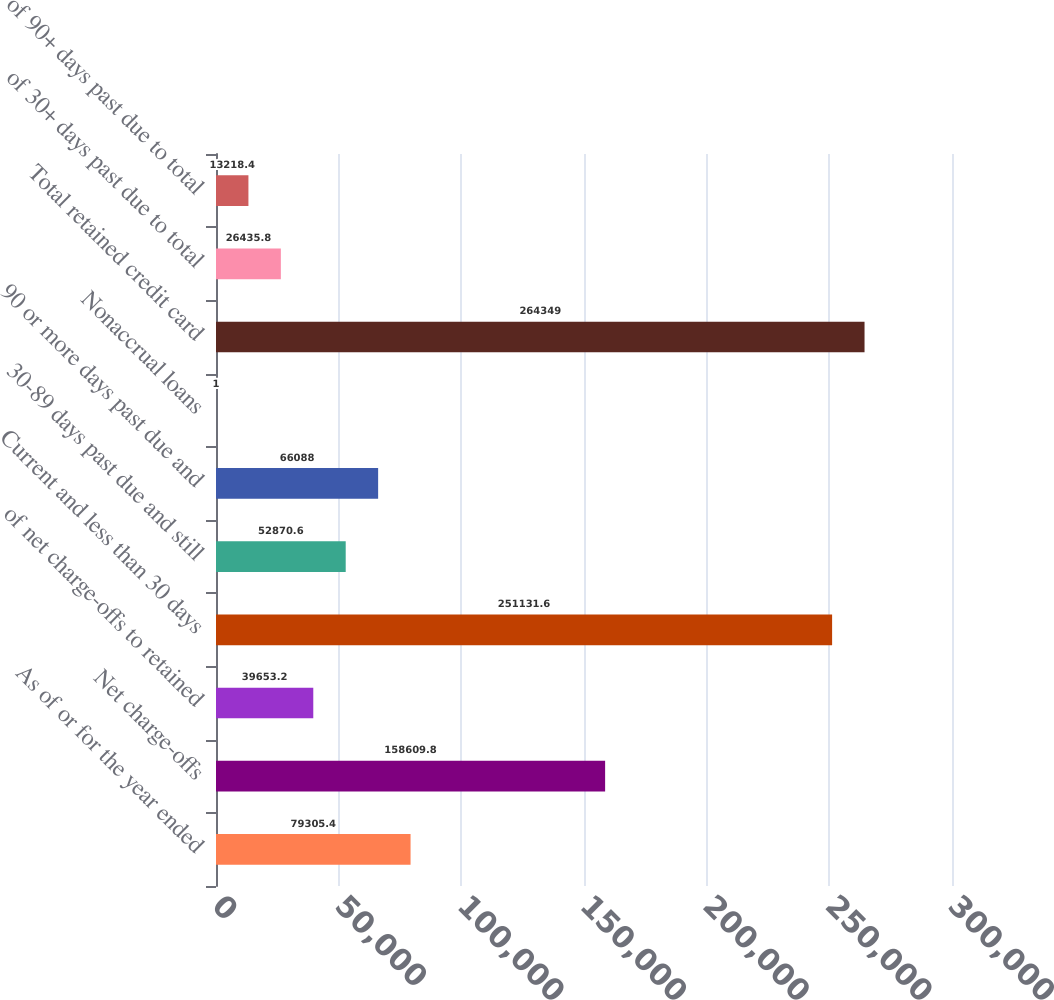Convert chart to OTSL. <chart><loc_0><loc_0><loc_500><loc_500><bar_chart><fcel>As of or for the year ended<fcel>Net charge-offs<fcel>of net charge-offs to retained<fcel>Current and less than 30 days<fcel>30-89 days past due and still<fcel>90 or more days past due and<fcel>Nonaccrual loans<fcel>Total retained credit card<fcel>of 30+ days past due to total<fcel>of 90+ days past due to total<nl><fcel>79305.4<fcel>158610<fcel>39653.2<fcel>251132<fcel>52870.6<fcel>66088<fcel>1<fcel>264349<fcel>26435.8<fcel>13218.4<nl></chart> 